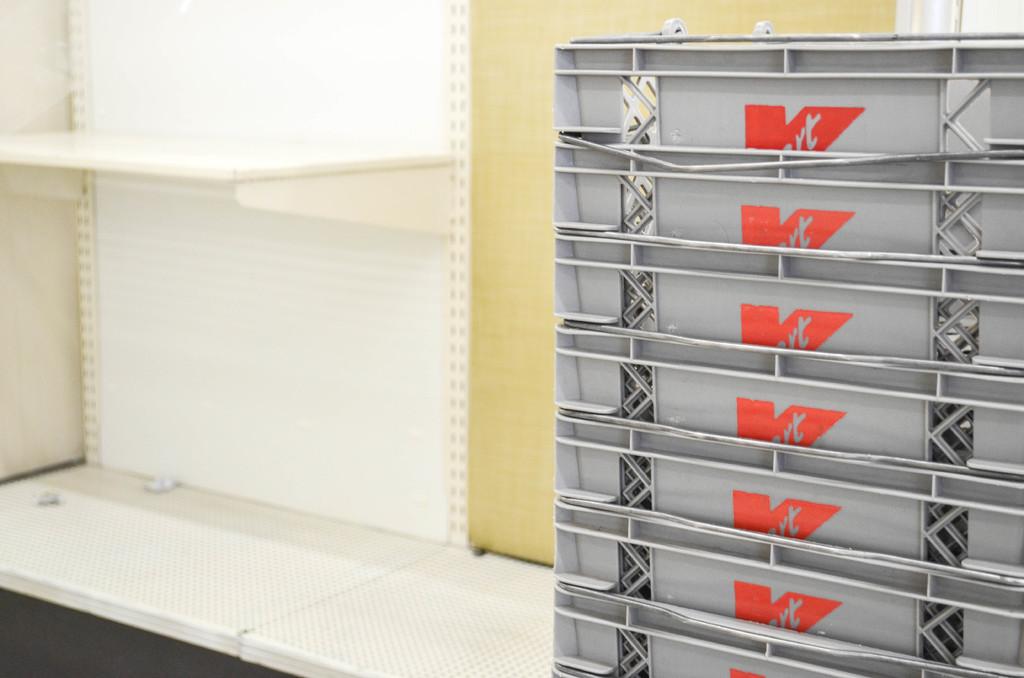What is the name of the store on the shopping carts?
Your answer should be very brief. Kmart. 